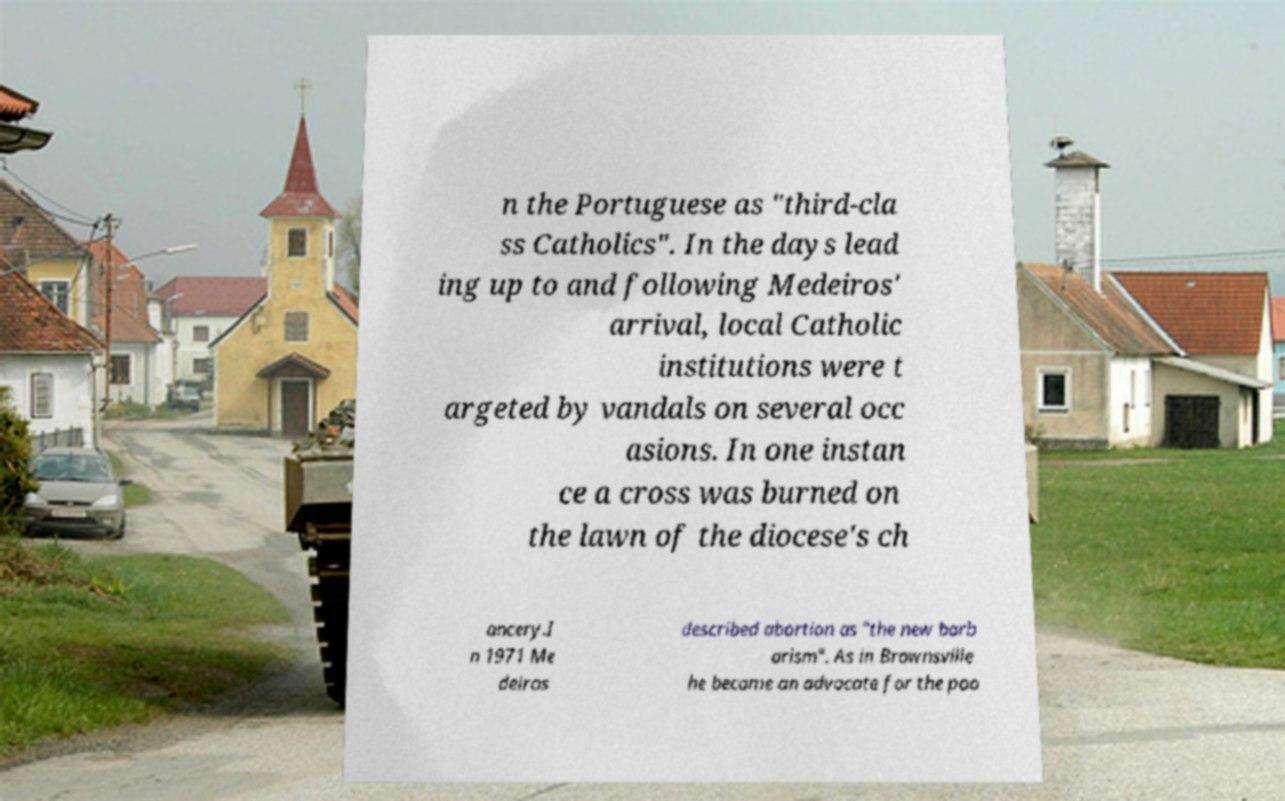Please read and relay the text visible in this image. What does it say? n the Portuguese as "third-cla ss Catholics". In the days lead ing up to and following Medeiros' arrival, local Catholic institutions were t argeted by vandals on several occ asions. In one instan ce a cross was burned on the lawn of the diocese's ch ancery.I n 1971 Me deiros described abortion as "the new barb arism". As in Brownsville he became an advocate for the poo 